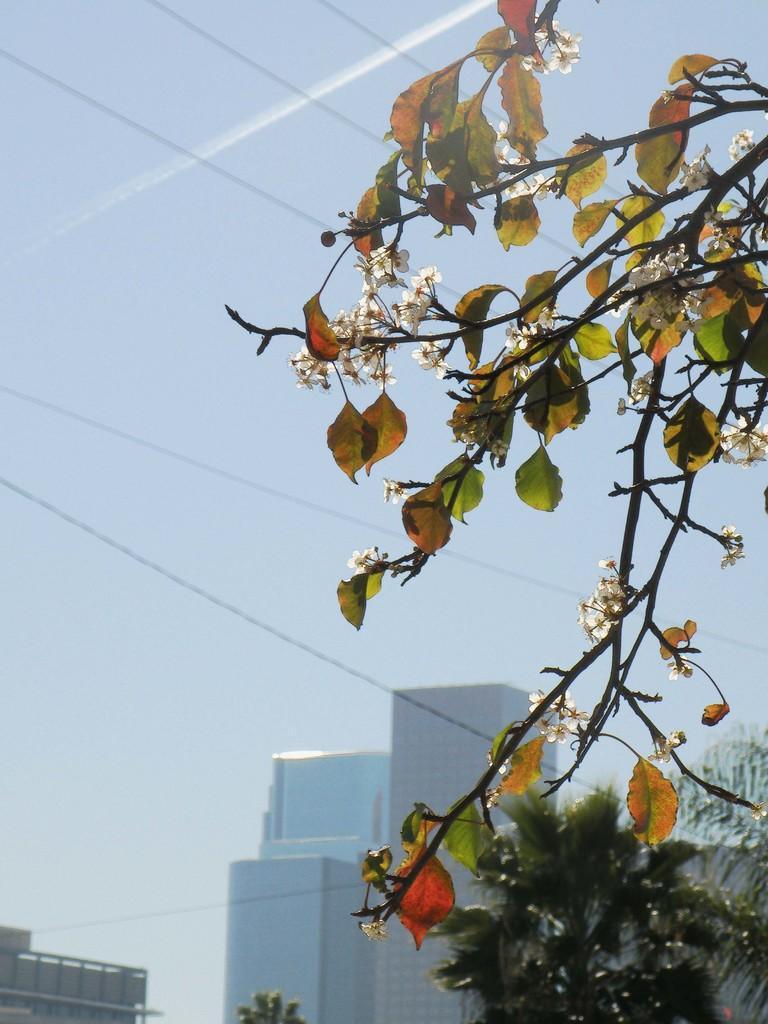In one or two sentences, can you explain what this image depicts? In this image we can see group of flowers and leaves on branches of a tree. In the background, we can see a group of trees, buildings and the sky. 